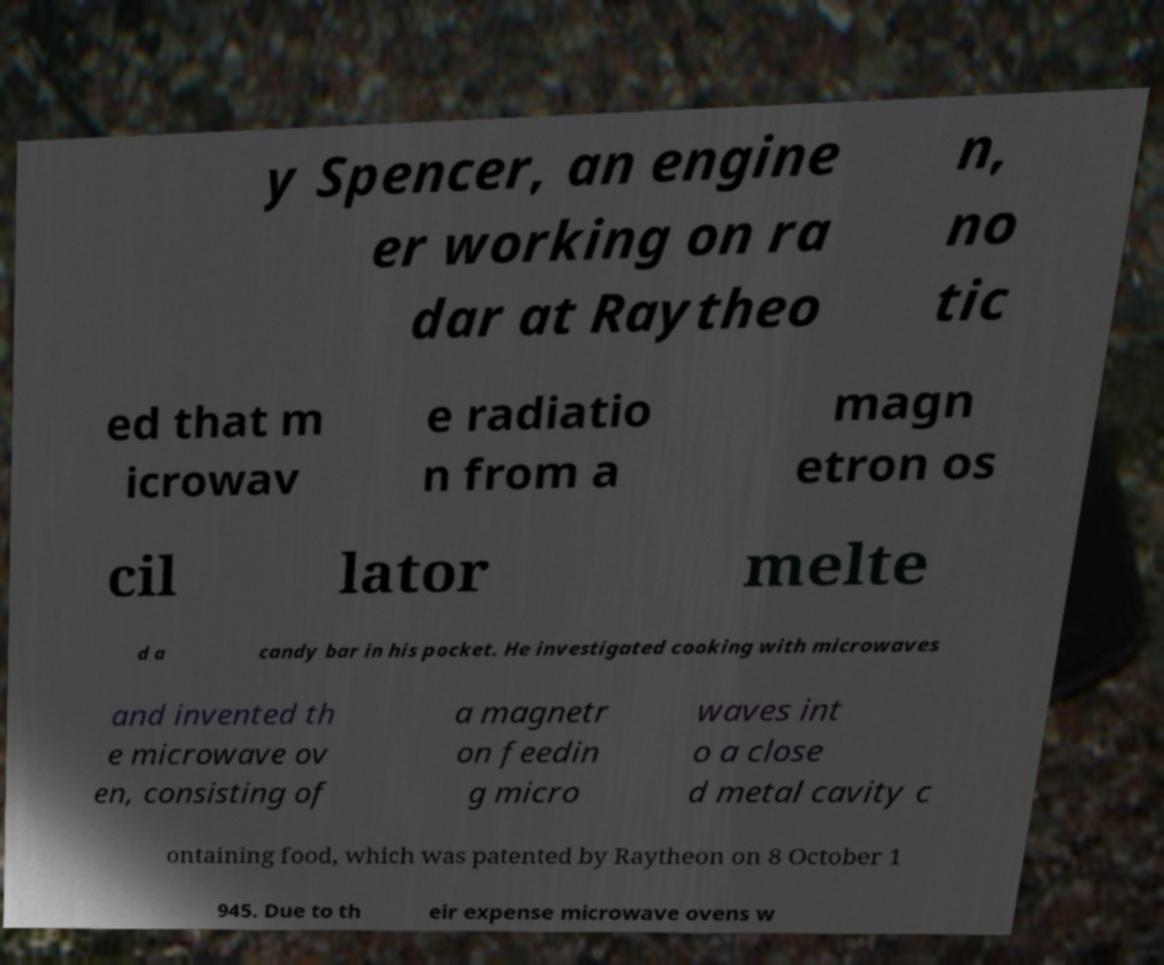Please identify and transcribe the text found in this image. y Spencer, an engine er working on ra dar at Raytheo n, no tic ed that m icrowav e radiatio n from a magn etron os cil lator melte d a candy bar in his pocket. He investigated cooking with microwaves and invented th e microwave ov en, consisting of a magnetr on feedin g micro waves int o a close d metal cavity c ontaining food, which was patented by Raytheon on 8 October 1 945. Due to th eir expense microwave ovens w 